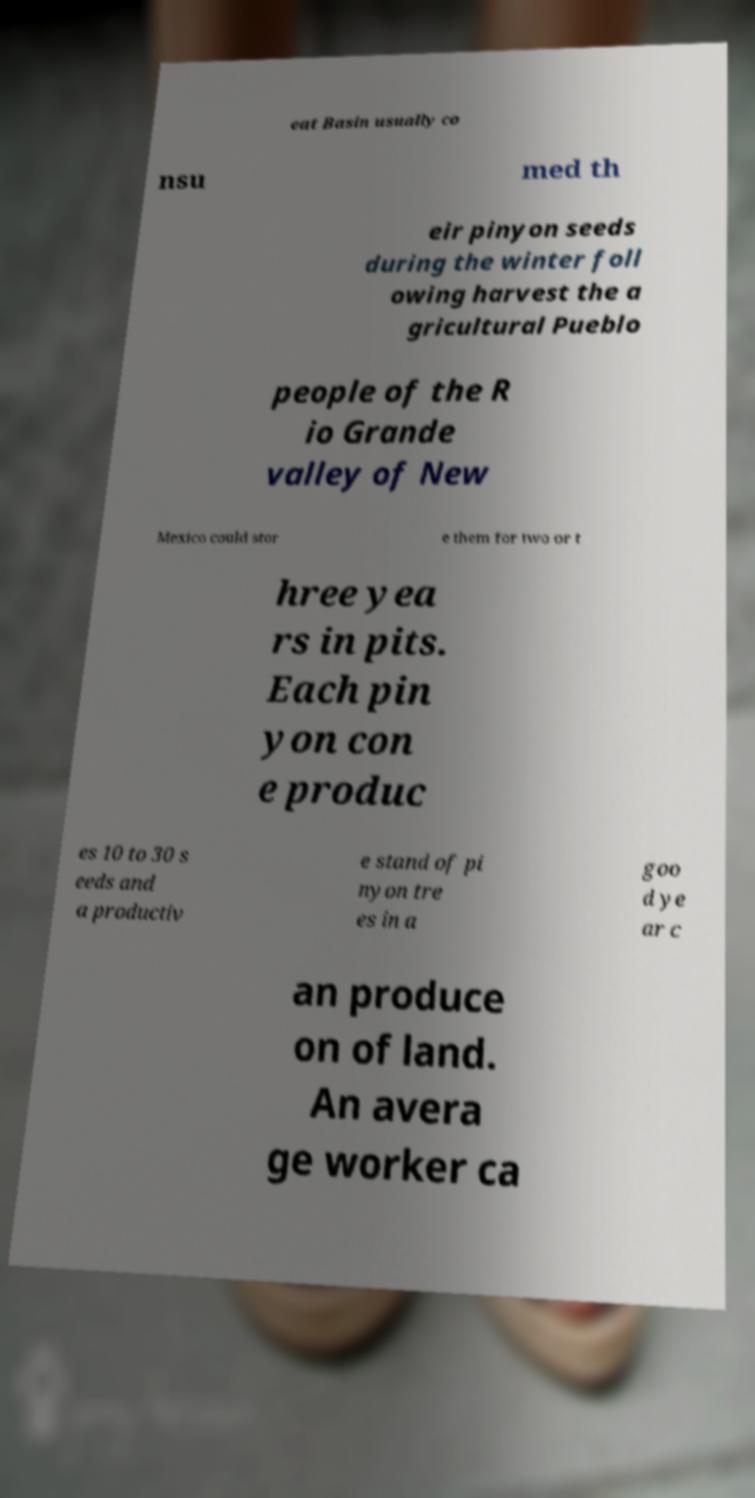Can you accurately transcribe the text from the provided image for me? eat Basin usually co nsu med th eir pinyon seeds during the winter foll owing harvest the a gricultural Pueblo people of the R io Grande valley of New Mexico could stor e them for two or t hree yea rs in pits. Each pin yon con e produc es 10 to 30 s eeds and a productiv e stand of pi nyon tre es in a goo d ye ar c an produce on of land. An avera ge worker ca 